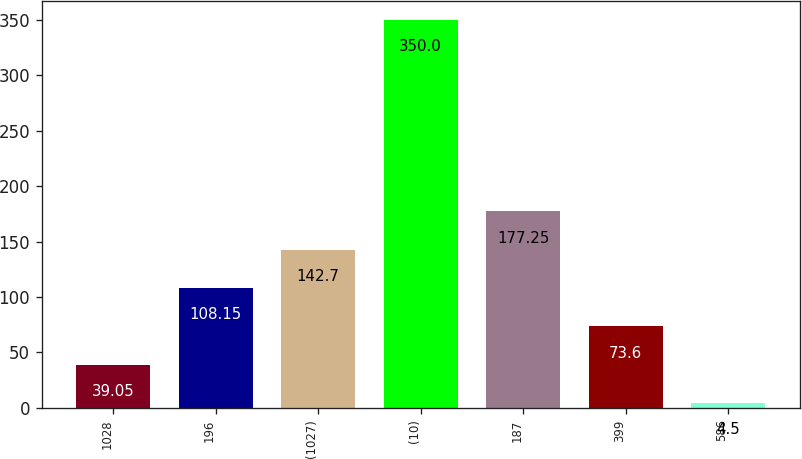Convert chart to OTSL. <chart><loc_0><loc_0><loc_500><loc_500><bar_chart><fcel>1028<fcel>196<fcel>(1027)<fcel>(10)<fcel>187<fcel>399<fcel>586<nl><fcel>39.05<fcel>108.15<fcel>142.7<fcel>350<fcel>177.25<fcel>73.6<fcel>4.5<nl></chart> 